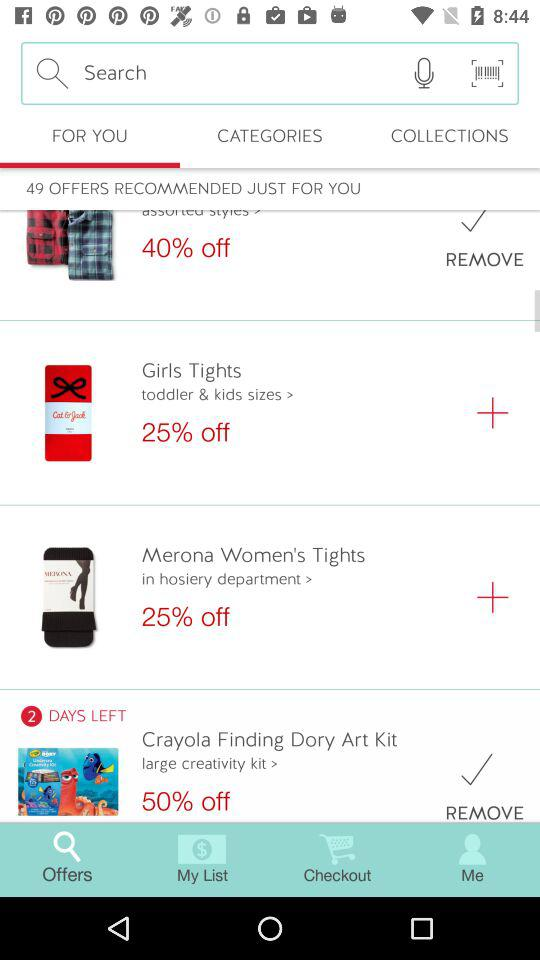How many items are on sale?
Answer the question using a single word or phrase. 4 